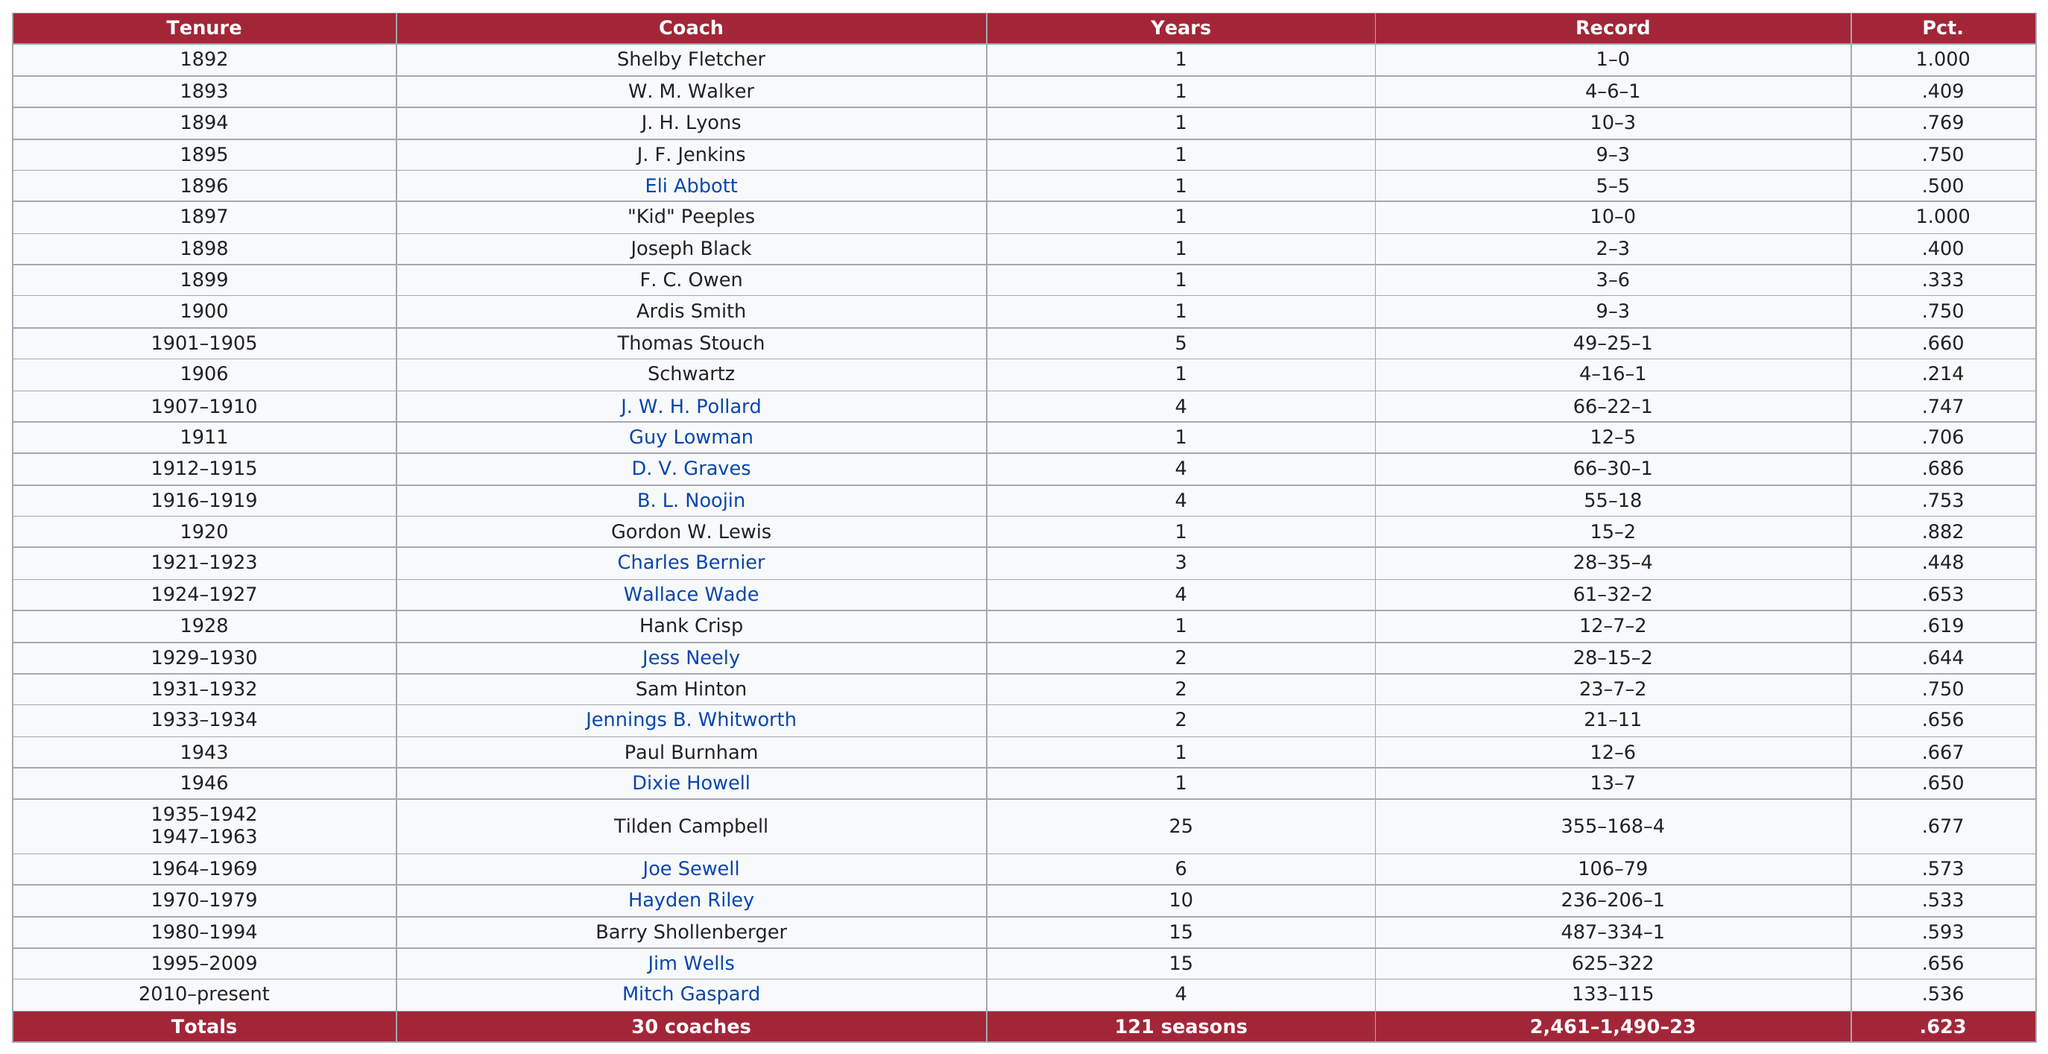Mention a couple of crucial points in this snapshot. Joe Sewell was the only coach who served for a period of six years. Before Tilden Campbell became the coach, Dixie Howell was the coach. Wallace Wade was a coach for a total of 4 years. Ardis Smith's previous coach, F. C. Owen, served before her. Joseph Black was a coach for one year. 